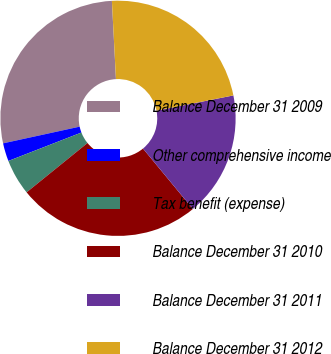Convert chart. <chart><loc_0><loc_0><loc_500><loc_500><pie_chart><fcel>Balance December 31 2009<fcel>Other comprehensive income<fcel>Tax benefit (expense)<fcel>Balance December 31 2010<fcel>Balance December 31 2011<fcel>Balance December 31 2012<nl><fcel>27.59%<fcel>2.49%<fcel>4.93%<fcel>25.15%<fcel>17.13%<fcel>22.71%<nl></chart> 